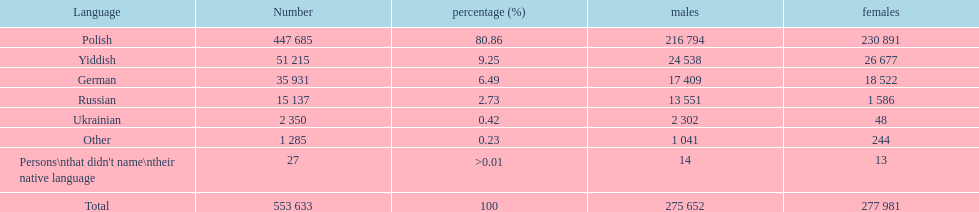How many speakers (of any language) are shown on the table? 553 633. 